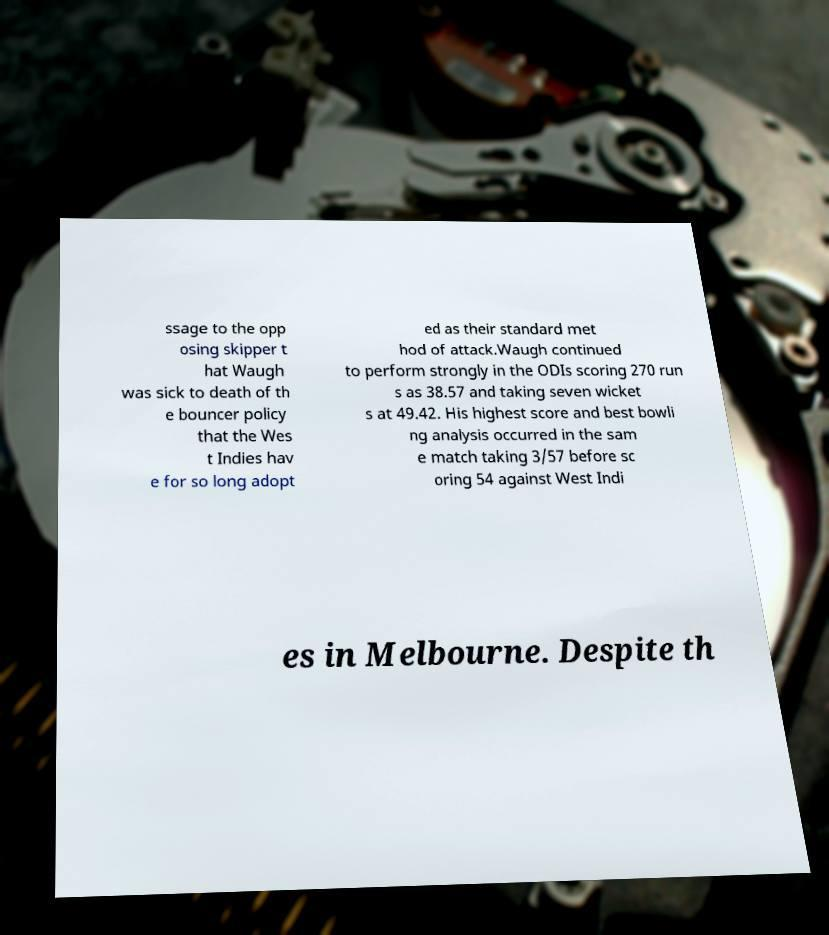Can you accurately transcribe the text from the provided image for me? ssage to the opp osing skipper t hat Waugh was sick to death of th e bouncer policy that the Wes t Indies hav e for so long adopt ed as their standard met hod of attack.Waugh continued to perform strongly in the ODIs scoring 270 run s as 38.57 and taking seven wicket s at 49.42. His highest score and best bowli ng analysis occurred in the sam e match taking 3/57 before sc oring 54 against West Indi es in Melbourne. Despite th 